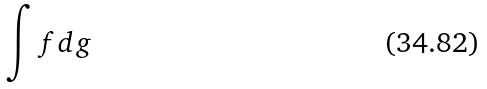Convert formula to latex. <formula><loc_0><loc_0><loc_500><loc_500>\int f d g</formula> 